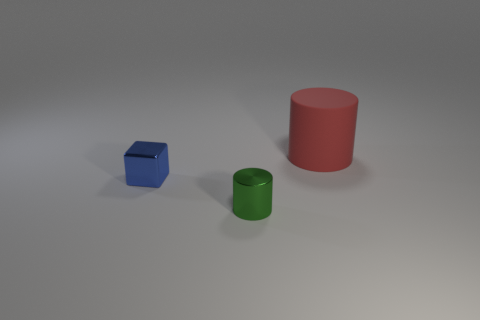How many other objects are there of the same size as the blue metallic cube?
Make the answer very short. 1. There is a large red object; is its shape the same as the small thing behind the metal cylinder?
Your answer should be very brief. No. What number of shiny things are either blue balls or red cylinders?
Offer a terse response. 0. Are there any small metal objects that have the same color as the big thing?
Provide a succinct answer. No. Are any green metallic cylinders visible?
Ensure brevity in your answer.  Yes. Is the blue shiny thing the same shape as the large red matte thing?
Ensure brevity in your answer.  No. What number of big objects are red cylinders or shiny blocks?
Provide a succinct answer. 1. The big thing has what color?
Ensure brevity in your answer.  Red. There is a small thing that is behind the cylinder that is to the left of the big red rubber object; what shape is it?
Make the answer very short. Cube. Is there a cyan cube made of the same material as the blue thing?
Offer a terse response. No. 